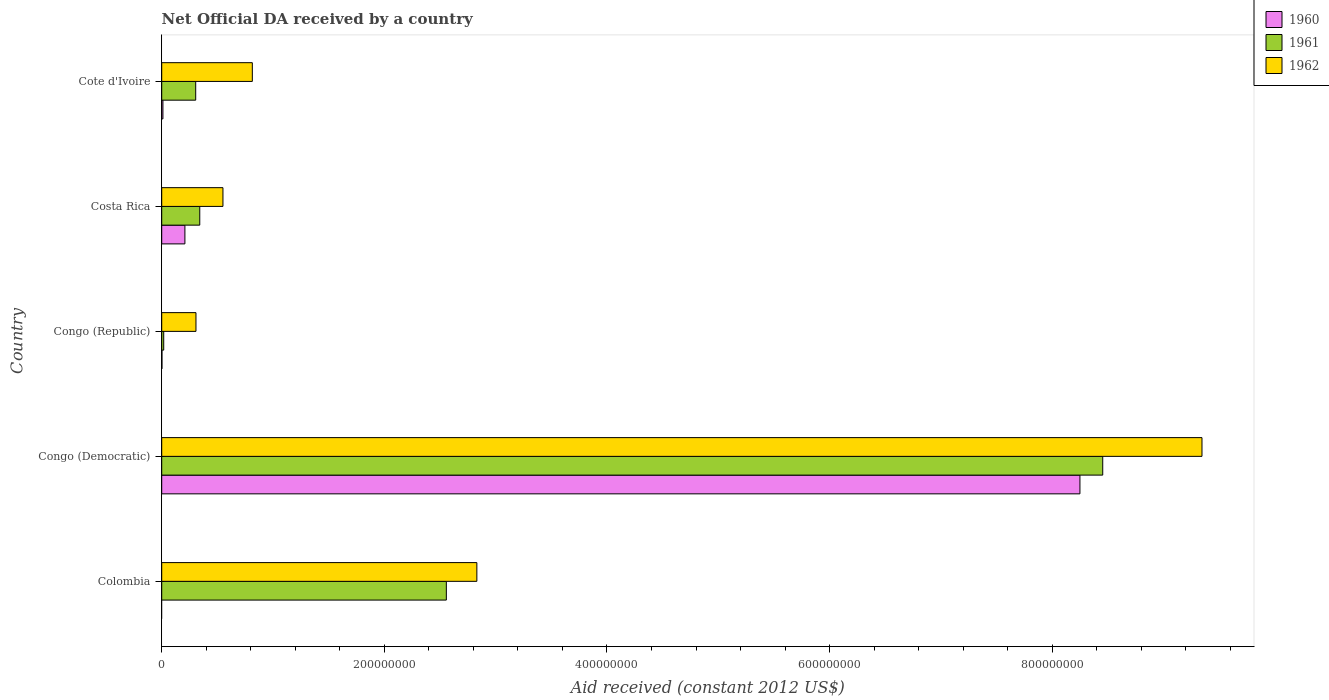How many groups of bars are there?
Your answer should be very brief. 5. How many bars are there on the 1st tick from the top?
Provide a succinct answer. 3. In how many cases, is the number of bars for a given country not equal to the number of legend labels?
Offer a very short reply. 1. What is the net official development assistance aid received in 1962 in Congo (Democratic)?
Ensure brevity in your answer.  9.35e+08. Across all countries, what is the maximum net official development assistance aid received in 1961?
Your response must be concise. 8.45e+08. Across all countries, what is the minimum net official development assistance aid received in 1962?
Offer a terse response. 3.08e+07. In which country was the net official development assistance aid received in 1960 maximum?
Ensure brevity in your answer.  Congo (Democratic). What is the total net official development assistance aid received in 1961 in the graph?
Make the answer very short. 1.17e+09. What is the difference between the net official development assistance aid received in 1961 in Congo (Democratic) and that in Congo (Republic)?
Offer a terse response. 8.44e+08. What is the difference between the net official development assistance aid received in 1961 in Costa Rica and the net official development assistance aid received in 1962 in Congo (Democratic)?
Provide a succinct answer. -9.00e+08. What is the average net official development assistance aid received in 1961 per country?
Your response must be concise. 2.34e+08. What is the difference between the net official development assistance aid received in 1962 and net official development assistance aid received in 1960 in Cote d'Ivoire?
Ensure brevity in your answer.  8.03e+07. In how many countries, is the net official development assistance aid received in 1962 greater than 200000000 US$?
Keep it short and to the point. 2. What is the ratio of the net official development assistance aid received in 1960 in Costa Rica to that in Cote d'Ivoire?
Provide a succinct answer. 19.11. Is the net official development assistance aid received in 1961 in Congo (Republic) less than that in Cote d'Ivoire?
Provide a short and direct response. Yes. What is the difference between the highest and the second highest net official development assistance aid received in 1960?
Offer a very short reply. 8.04e+08. What is the difference between the highest and the lowest net official development assistance aid received in 1960?
Provide a short and direct response. 8.25e+08. How many bars are there?
Offer a very short reply. 14. Are all the bars in the graph horizontal?
Your response must be concise. Yes. Does the graph contain grids?
Give a very brief answer. No. How many legend labels are there?
Provide a short and direct response. 3. What is the title of the graph?
Provide a short and direct response. Net Official DA received by a country. Does "1965" appear as one of the legend labels in the graph?
Offer a terse response. No. What is the label or title of the X-axis?
Make the answer very short. Aid received (constant 2012 US$). What is the label or title of the Y-axis?
Give a very brief answer. Country. What is the Aid received (constant 2012 US$) in 1961 in Colombia?
Offer a terse response. 2.56e+08. What is the Aid received (constant 2012 US$) in 1962 in Colombia?
Give a very brief answer. 2.83e+08. What is the Aid received (constant 2012 US$) of 1960 in Congo (Democratic)?
Offer a very short reply. 8.25e+08. What is the Aid received (constant 2012 US$) in 1961 in Congo (Democratic)?
Your answer should be compact. 8.45e+08. What is the Aid received (constant 2012 US$) of 1962 in Congo (Democratic)?
Your response must be concise. 9.35e+08. What is the Aid received (constant 2012 US$) in 1960 in Congo (Republic)?
Offer a terse response. 2.20e+05. What is the Aid received (constant 2012 US$) of 1961 in Congo (Republic)?
Offer a very short reply. 1.80e+06. What is the Aid received (constant 2012 US$) in 1962 in Congo (Republic)?
Offer a very short reply. 3.08e+07. What is the Aid received (constant 2012 US$) in 1960 in Costa Rica?
Ensure brevity in your answer.  2.08e+07. What is the Aid received (constant 2012 US$) of 1961 in Costa Rica?
Provide a succinct answer. 3.42e+07. What is the Aid received (constant 2012 US$) of 1962 in Costa Rica?
Your answer should be compact. 5.50e+07. What is the Aid received (constant 2012 US$) of 1960 in Cote d'Ivoire?
Provide a succinct answer. 1.09e+06. What is the Aid received (constant 2012 US$) of 1961 in Cote d'Ivoire?
Give a very brief answer. 3.05e+07. What is the Aid received (constant 2012 US$) of 1962 in Cote d'Ivoire?
Your response must be concise. 8.14e+07. Across all countries, what is the maximum Aid received (constant 2012 US$) in 1960?
Your answer should be compact. 8.25e+08. Across all countries, what is the maximum Aid received (constant 2012 US$) of 1961?
Give a very brief answer. 8.45e+08. Across all countries, what is the maximum Aid received (constant 2012 US$) in 1962?
Your response must be concise. 9.35e+08. Across all countries, what is the minimum Aid received (constant 2012 US$) in 1960?
Give a very brief answer. 0. Across all countries, what is the minimum Aid received (constant 2012 US$) of 1961?
Offer a terse response. 1.80e+06. Across all countries, what is the minimum Aid received (constant 2012 US$) of 1962?
Keep it short and to the point. 3.08e+07. What is the total Aid received (constant 2012 US$) in 1960 in the graph?
Your answer should be compact. 8.47e+08. What is the total Aid received (constant 2012 US$) of 1961 in the graph?
Your answer should be compact. 1.17e+09. What is the total Aid received (constant 2012 US$) in 1962 in the graph?
Offer a terse response. 1.38e+09. What is the difference between the Aid received (constant 2012 US$) in 1961 in Colombia and that in Congo (Democratic)?
Offer a very short reply. -5.90e+08. What is the difference between the Aid received (constant 2012 US$) of 1962 in Colombia and that in Congo (Democratic)?
Make the answer very short. -6.51e+08. What is the difference between the Aid received (constant 2012 US$) of 1961 in Colombia and that in Congo (Republic)?
Offer a terse response. 2.54e+08. What is the difference between the Aid received (constant 2012 US$) of 1962 in Colombia and that in Congo (Republic)?
Your response must be concise. 2.52e+08. What is the difference between the Aid received (constant 2012 US$) in 1961 in Colombia and that in Costa Rica?
Your answer should be compact. 2.22e+08. What is the difference between the Aid received (constant 2012 US$) of 1962 in Colombia and that in Costa Rica?
Your answer should be compact. 2.28e+08. What is the difference between the Aid received (constant 2012 US$) of 1961 in Colombia and that in Cote d'Ivoire?
Give a very brief answer. 2.25e+08. What is the difference between the Aid received (constant 2012 US$) in 1962 in Colombia and that in Cote d'Ivoire?
Your answer should be very brief. 2.02e+08. What is the difference between the Aid received (constant 2012 US$) in 1960 in Congo (Democratic) and that in Congo (Republic)?
Provide a short and direct response. 8.25e+08. What is the difference between the Aid received (constant 2012 US$) of 1961 in Congo (Democratic) and that in Congo (Republic)?
Keep it short and to the point. 8.44e+08. What is the difference between the Aid received (constant 2012 US$) in 1962 in Congo (Democratic) and that in Congo (Republic)?
Ensure brevity in your answer.  9.04e+08. What is the difference between the Aid received (constant 2012 US$) in 1960 in Congo (Democratic) and that in Costa Rica?
Offer a very short reply. 8.04e+08. What is the difference between the Aid received (constant 2012 US$) in 1961 in Congo (Democratic) and that in Costa Rica?
Your answer should be compact. 8.11e+08. What is the difference between the Aid received (constant 2012 US$) in 1962 in Congo (Democratic) and that in Costa Rica?
Keep it short and to the point. 8.79e+08. What is the difference between the Aid received (constant 2012 US$) of 1960 in Congo (Democratic) and that in Cote d'Ivoire?
Keep it short and to the point. 8.24e+08. What is the difference between the Aid received (constant 2012 US$) in 1961 in Congo (Democratic) and that in Cote d'Ivoire?
Your response must be concise. 8.15e+08. What is the difference between the Aid received (constant 2012 US$) of 1962 in Congo (Democratic) and that in Cote d'Ivoire?
Make the answer very short. 8.53e+08. What is the difference between the Aid received (constant 2012 US$) of 1960 in Congo (Republic) and that in Costa Rica?
Keep it short and to the point. -2.06e+07. What is the difference between the Aid received (constant 2012 US$) of 1961 in Congo (Republic) and that in Costa Rica?
Ensure brevity in your answer.  -3.24e+07. What is the difference between the Aid received (constant 2012 US$) in 1962 in Congo (Republic) and that in Costa Rica?
Your response must be concise. -2.42e+07. What is the difference between the Aid received (constant 2012 US$) of 1960 in Congo (Republic) and that in Cote d'Ivoire?
Make the answer very short. -8.70e+05. What is the difference between the Aid received (constant 2012 US$) in 1961 in Congo (Republic) and that in Cote d'Ivoire?
Offer a terse response. -2.87e+07. What is the difference between the Aid received (constant 2012 US$) in 1962 in Congo (Republic) and that in Cote d'Ivoire?
Make the answer very short. -5.06e+07. What is the difference between the Aid received (constant 2012 US$) of 1960 in Costa Rica and that in Cote d'Ivoire?
Your answer should be very brief. 1.97e+07. What is the difference between the Aid received (constant 2012 US$) in 1961 in Costa Rica and that in Cote d'Ivoire?
Offer a very short reply. 3.65e+06. What is the difference between the Aid received (constant 2012 US$) of 1962 in Costa Rica and that in Cote d'Ivoire?
Your answer should be compact. -2.64e+07. What is the difference between the Aid received (constant 2012 US$) of 1961 in Colombia and the Aid received (constant 2012 US$) of 1962 in Congo (Democratic)?
Your response must be concise. -6.79e+08. What is the difference between the Aid received (constant 2012 US$) in 1961 in Colombia and the Aid received (constant 2012 US$) in 1962 in Congo (Republic)?
Provide a short and direct response. 2.25e+08. What is the difference between the Aid received (constant 2012 US$) in 1961 in Colombia and the Aid received (constant 2012 US$) in 1962 in Costa Rica?
Offer a very short reply. 2.01e+08. What is the difference between the Aid received (constant 2012 US$) of 1961 in Colombia and the Aid received (constant 2012 US$) of 1962 in Cote d'Ivoire?
Ensure brevity in your answer.  1.74e+08. What is the difference between the Aid received (constant 2012 US$) in 1960 in Congo (Democratic) and the Aid received (constant 2012 US$) in 1961 in Congo (Republic)?
Your answer should be compact. 8.23e+08. What is the difference between the Aid received (constant 2012 US$) in 1960 in Congo (Democratic) and the Aid received (constant 2012 US$) in 1962 in Congo (Republic)?
Your response must be concise. 7.94e+08. What is the difference between the Aid received (constant 2012 US$) of 1961 in Congo (Democratic) and the Aid received (constant 2012 US$) of 1962 in Congo (Republic)?
Offer a terse response. 8.15e+08. What is the difference between the Aid received (constant 2012 US$) in 1960 in Congo (Democratic) and the Aid received (constant 2012 US$) in 1961 in Costa Rica?
Provide a short and direct response. 7.91e+08. What is the difference between the Aid received (constant 2012 US$) in 1960 in Congo (Democratic) and the Aid received (constant 2012 US$) in 1962 in Costa Rica?
Provide a succinct answer. 7.70e+08. What is the difference between the Aid received (constant 2012 US$) of 1961 in Congo (Democratic) and the Aid received (constant 2012 US$) of 1962 in Costa Rica?
Offer a terse response. 7.90e+08. What is the difference between the Aid received (constant 2012 US$) of 1960 in Congo (Democratic) and the Aid received (constant 2012 US$) of 1961 in Cote d'Ivoire?
Keep it short and to the point. 7.94e+08. What is the difference between the Aid received (constant 2012 US$) of 1960 in Congo (Democratic) and the Aid received (constant 2012 US$) of 1962 in Cote d'Ivoire?
Your answer should be compact. 7.43e+08. What is the difference between the Aid received (constant 2012 US$) in 1961 in Congo (Democratic) and the Aid received (constant 2012 US$) in 1962 in Cote d'Ivoire?
Make the answer very short. 7.64e+08. What is the difference between the Aid received (constant 2012 US$) in 1960 in Congo (Republic) and the Aid received (constant 2012 US$) in 1961 in Costa Rica?
Your response must be concise. -3.40e+07. What is the difference between the Aid received (constant 2012 US$) of 1960 in Congo (Republic) and the Aid received (constant 2012 US$) of 1962 in Costa Rica?
Your answer should be compact. -5.48e+07. What is the difference between the Aid received (constant 2012 US$) of 1961 in Congo (Republic) and the Aid received (constant 2012 US$) of 1962 in Costa Rica?
Your answer should be very brief. -5.32e+07. What is the difference between the Aid received (constant 2012 US$) in 1960 in Congo (Republic) and the Aid received (constant 2012 US$) in 1961 in Cote d'Ivoire?
Offer a terse response. -3.03e+07. What is the difference between the Aid received (constant 2012 US$) of 1960 in Congo (Republic) and the Aid received (constant 2012 US$) of 1962 in Cote d'Ivoire?
Keep it short and to the point. -8.12e+07. What is the difference between the Aid received (constant 2012 US$) of 1961 in Congo (Republic) and the Aid received (constant 2012 US$) of 1962 in Cote d'Ivoire?
Offer a terse response. -7.96e+07. What is the difference between the Aid received (constant 2012 US$) in 1960 in Costa Rica and the Aid received (constant 2012 US$) in 1961 in Cote d'Ivoire?
Make the answer very short. -9.71e+06. What is the difference between the Aid received (constant 2012 US$) of 1960 in Costa Rica and the Aid received (constant 2012 US$) of 1962 in Cote d'Ivoire?
Your response must be concise. -6.06e+07. What is the difference between the Aid received (constant 2012 US$) in 1961 in Costa Rica and the Aid received (constant 2012 US$) in 1962 in Cote d'Ivoire?
Offer a terse response. -4.72e+07. What is the average Aid received (constant 2012 US$) in 1960 per country?
Your answer should be very brief. 1.69e+08. What is the average Aid received (constant 2012 US$) of 1961 per country?
Your response must be concise. 2.34e+08. What is the average Aid received (constant 2012 US$) of 1962 per country?
Offer a terse response. 2.77e+08. What is the difference between the Aid received (constant 2012 US$) of 1961 and Aid received (constant 2012 US$) of 1962 in Colombia?
Offer a very short reply. -2.74e+07. What is the difference between the Aid received (constant 2012 US$) of 1960 and Aid received (constant 2012 US$) of 1961 in Congo (Democratic)?
Your response must be concise. -2.05e+07. What is the difference between the Aid received (constant 2012 US$) of 1960 and Aid received (constant 2012 US$) of 1962 in Congo (Democratic)?
Offer a very short reply. -1.10e+08. What is the difference between the Aid received (constant 2012 US$) of 1961 and Aid received (constant 2012 US$) of 1962 in Congo (Democratic)?
Your answer should be compact. -8.92e+07. What is the difference between the Aid received (constant 2012 US$) in 1960 and Aid received (constant 2012 US$) in 1961 in Congo (Republic)?
Your answer should be compact. -1.58e+06. What is the difference between the Aid received (constant 2012 US$) of 1960 and Aid received (constant 2012 US$) of 1962 in Congo (Republic)?
Provide a short and direct response. -3.06e+07. What is the difference between the Aid received (constant 2012 US$) of 1961 and Aid received (constant 2012 US$) of 1962 in Congo (Republic)?
Make the answer very short. -2.90e+07. What is the difference between the Aid received (constant 2012 US$) in 1960 and Aid received (constant 2012 US$) in 1961 in Costa Rica?
Make the answer very short. -1.34e+07. What is the difference between the Aid received (constant 2012 US$) of 1960 and Aid received (constant 2012 US$) of 1962 in Costa Rica?
Ensure brevity in your answer.  -3.42e+07. What is the difference between the Aid received (constant 2012 US$) of 1961 and Aid received (constant 2012 US$) of 1962 in Costa Rica?
Offer a terse response. -2.08e+07. What is the difference between the Aid received (constant 2012 US$) of 1960 and Aid received (constant 2012 US$) of 1961 in Cote d'Ivoire?
Your response must be concise. -2.94e+07. What is the difference between the Aid received (constant 2012 US$) of 1960 and Aid received (constant 2012 US$) of 1962 in Cote d'Ivoire?
Give a very brief answer. -8.03e+07. What is the difference between the Aid received (constant 2012 US$) in 1961 and Aid received (constant 2012 US$) in 1962 in Cote d'Ivoire?
Provide a short and direct response. -5.09e+07. What is the ratio of the Aid received (constant 2012 US$) in 1961 in Colombia to that in Congo (Democratic)?
Provide a succinct answer. 0.3. What is the ratio of the Aid received (constant 2012 US$) of 1962 in Colombia to that in Congo (Democratic)?
Provide a succinct answer. 0.3. What is the ratio of the Aid received (constant 2012 US$) in 1961 in Colombia to that in Congo (Republic)?
Your answer should be very brief. 142.05. What is the ratio of the Aid received (constant 2012 US$) in 1962 in Colombia to that in Congo (Republic)?
Make the answer very short. 9.2. What is the ratio of the Aid received (constant 2012 US$) of 1961 in Colombia to that in Costa Rica?
Keep it short and to the point. 7.48. What is the ratio of the Aid received (constant 2012 US$) in 1962 in Colombia to that in Costa Rica?
Your response must be concise. 5.15. What is the ratio of the Aid received (constant 2012 US$) of 1961 in Colombia to that in Cote d'Ivoire?
Offer a terse response. 8.37. What is the ratio of the Aid received (constant 2012 US$) of 1962 in Colombia to that in Cote d'Ivoire?
Keep it short and to the point. 3.48. What is the ratio of the Aid received (constant 2012 US$) of 1960 in Congo (Democratic) to that in Congo (Republic)?
Give a very brief answer. 3749.45. What is the ratio of the Aid received (constant 2012 US$) of 1961 in Congo (Democratic) to that in Congo (Republic)?
Your answer should be compact. 469.64. What is the ratio of the Aid received (constant 2012 US$) in 1962 in Congo (Democratic) to that in Congo (Republic)?
Offer a very short reply. 30.36. What is the ratio of the Aid received (constant 2012 US$) in 1960 in Congo (Democratic) to that in Costa Rica?
Provide a short and direct response. 39.6. What is the ratio of the Aid received (constant 2012 US$) of 1961 in Congo (Democratic) to that in Costa Rica?
Offer a terse response. 24.73. What is the ratio of the Aid received (constant 2012 US$) of 1962 in Congo (Democratic) to that in Costa Rica?
Make the answer very short. 16.98. What is the ratio of the Aid received (constant 2012 US$) of 1960 in Congo (Democratic) to that in Cote d'Ivoire?
Your response must be concise. 756.77. What is the ratio of the Aid received (constant 2012 US$) of 1961 in Congo (Democratic) to that in Cote d'Ivoire?
Offer a terse response. 27.68. What is the ratio of the Aid received (constant 2012 US$) of 1962 in Congo (Democratic) to that in Cote d'Ivoire?
Ensure brevity in your answer.  11.48. What is the ratio of the Aid received (constant 2012 US$) of 1960 in Congo (Republic) to that in Costa Rica?
Offer a very short reply. 0.01. What is the ratio of the Aid received (constant 2012 US$) in 1961 in Congo (Republic) to that in Costa Rica?
Ensure brevity in your answer.  0.05. What is the ratio of the Aid received (constant 2012 US$) in 1962 in Congo (Republic) to that in Costa Rica?
Offer a very short reply. 0.56. What is the ratio of the Aid received (constant 2012 US$) in 1960 in Congo (Republic) to that in Cote d'Ivoire?
Provide a short and direct response. 0.2. What is the ratio of the Aid received (constant 2012 US$) of 1961 in Congo (Republic) to that in Cote d'Ivoire?
Your answer should be compact. 0.06. What is the ratio of the Aid received (constant 2012 US$) of 1962 in Congo (Republic) to that in Cote d'Ivoire?
Provide a short and direct response. 0.38. What is the ratio of the Aid received (constant 2012 US$) of 1960 in Costa Rica to that in Cote d'Ivoire?
Offer a terse response. 19.11. What is the ratio of the Aid received (constant 2012 US$) in 1961 in Costa Rica to that in Cote d'Ivoire?
Your answer should be very brief. 1.12. What is the ratio of the Aid received (constant 2012 US$) in 1962 in Costa Rica to that in Cote d'Ivoire?
Provide a succinct answer. 0.68. What is the difference between the highest and the second highest Aid received (constant 2012 US$) in 1960?
Your answer should be compact. 8.04e+08. What is the difference between the highest and the second highest Aid received (constant 2012 US$) of 1961?
Give a very brief answer. 5.90e+08. What is the difference between the highest and the second highest Aid received (constant 2012 US$) of 1962?
Provide a short and direct response. 6.51e+08. What is the difference between the highest and the lowest Aid received (constant 2012 US$) in 1960?
Offer a terse response. 8.25e+08. What is the difference between the highest and the lowest Aid received (constant 2012 US$) in 1961?
Offer a very short reply. 8.44e+08. What is the difference between the highest and the lowest Aid received (constant 2012 US$) in 1962?
Give a very brief answer. 9.04e+08. 